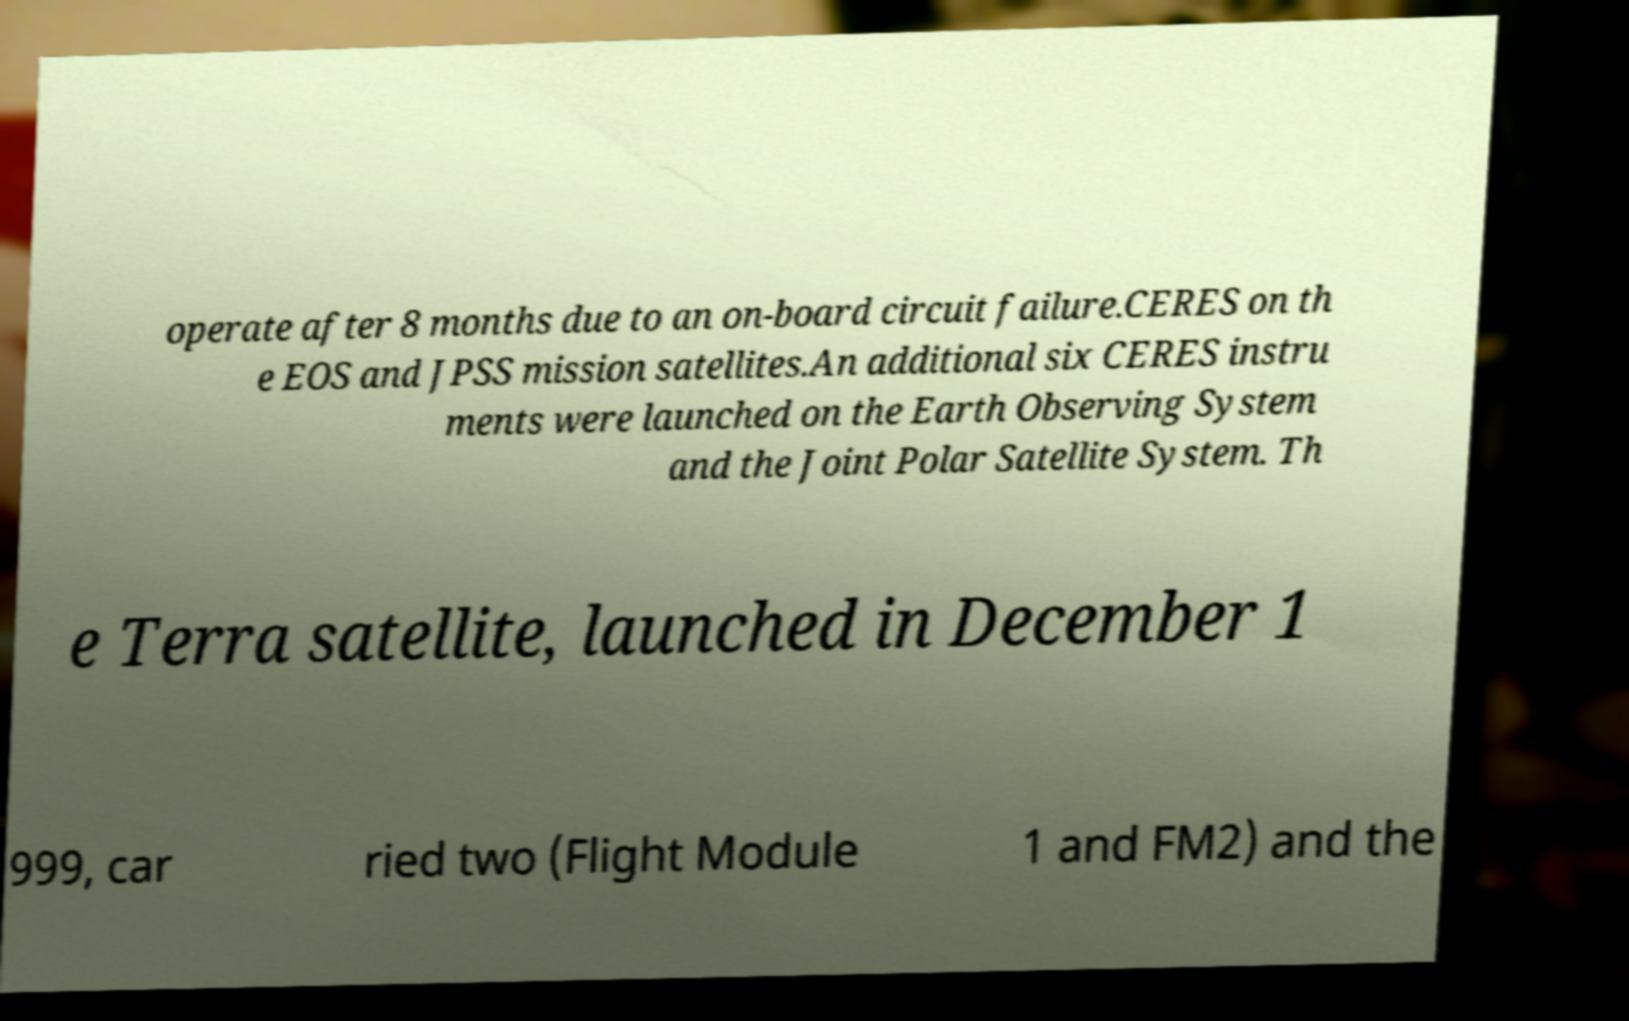What messages or text are displayed in this image? I need them in a readable, typed format. operate after 8 months due to an on-board circuit failure.CERES on th e EOS and JPSS mission satellites.An additional six CERES instru ments were launched on the Earth Observing System and the Joint Polar Satellite System. Th e Terra satellite, launched in December 1 999, car ried two (Flight Module 1 and FM2) and the 